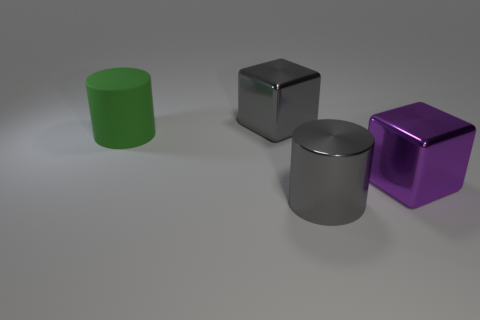What is the shape of the big metal object that is the same color as the large metal cylinder?
Make the answer very short. Cube. What number of other objects are the same size as the gray cube?
Provide a short and direct response. 3. What shape is the gray metal object that is behind the big metal thing on the right side of the metal cylinder on the left side of the large purple cube?
Keep it short and to the point. Cube. There is a object that is behind the metal cylinder and on the right side of the gray cube; what shape is it?
Give a very brief answer. Cube. How many things are large shiny things or objects in front of the rubber cylinder?
Your answer should be very brief. 3. Are the large green thing and the gray block made of the same material?
Your answer should be compact. No. How many other objects are there of the same shape as the large green matte thing?
Provide a short and direct response. 1. There is a thing that is in front of the big gray metallic block and behind the large purple shiny thing; what size is it?
Provide a succinct answer. Large. How many rubber things are yellow cylinders or gray cubes?
Give a very brief answer. 0. There is a large metal thing that is behind the green rubber thing; does it have the same shape as the thing on the right side of the metal cylinder?
Provide a succinct answer. Yes. 